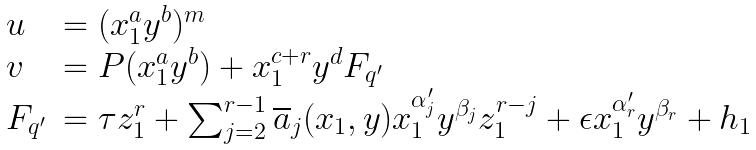Convert formula to latex. <formula><loc_0><loc_0><loc_500><loc_500>\begin{array} { l l } u & = ( x _ { 1 } ^ { a } y ^ { b } ) ^ { m } \\ v & = P ( x _ { 1 } ^ { a } y ^ { b } ) + x _ { 1 } ^ { c + r } y ^ { d } F _ { q ^ { \prime } } \\ F _ { q ^ { \prime } } & = \tau z _ { 1 } ^ { r } + \sum _ { j = 2 } ^ { r - 1 } \overline { a } _ { j } ( x _ { 1 } , y ) x _ { 1 } ^ { \alpha _ { j } ^ { \prime } } y ^ { \beta _ { j } } z _ { 1 } ^ { r - j } + \epsilon x _ { 1 } ^ { \alpha _ { r } ^ { \prime } } y ^ { \beta _ { r } } + h _ { 1 } \end{array}</formula> 